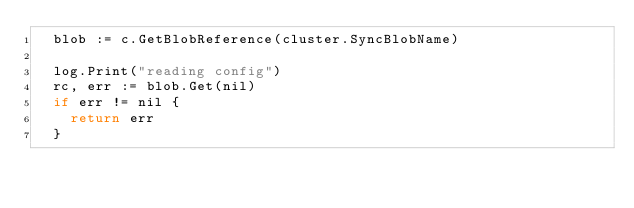Convert code to text. <code><loc_0><loc_0><loc_500><loc_500><_Go_>	blob := c.GetBlobReference(cluster.SyncBlobName)

	log.Print("reading config")
	rc, err := blob.Get(nil)
	if err != nil {
		return err
	}</code> 